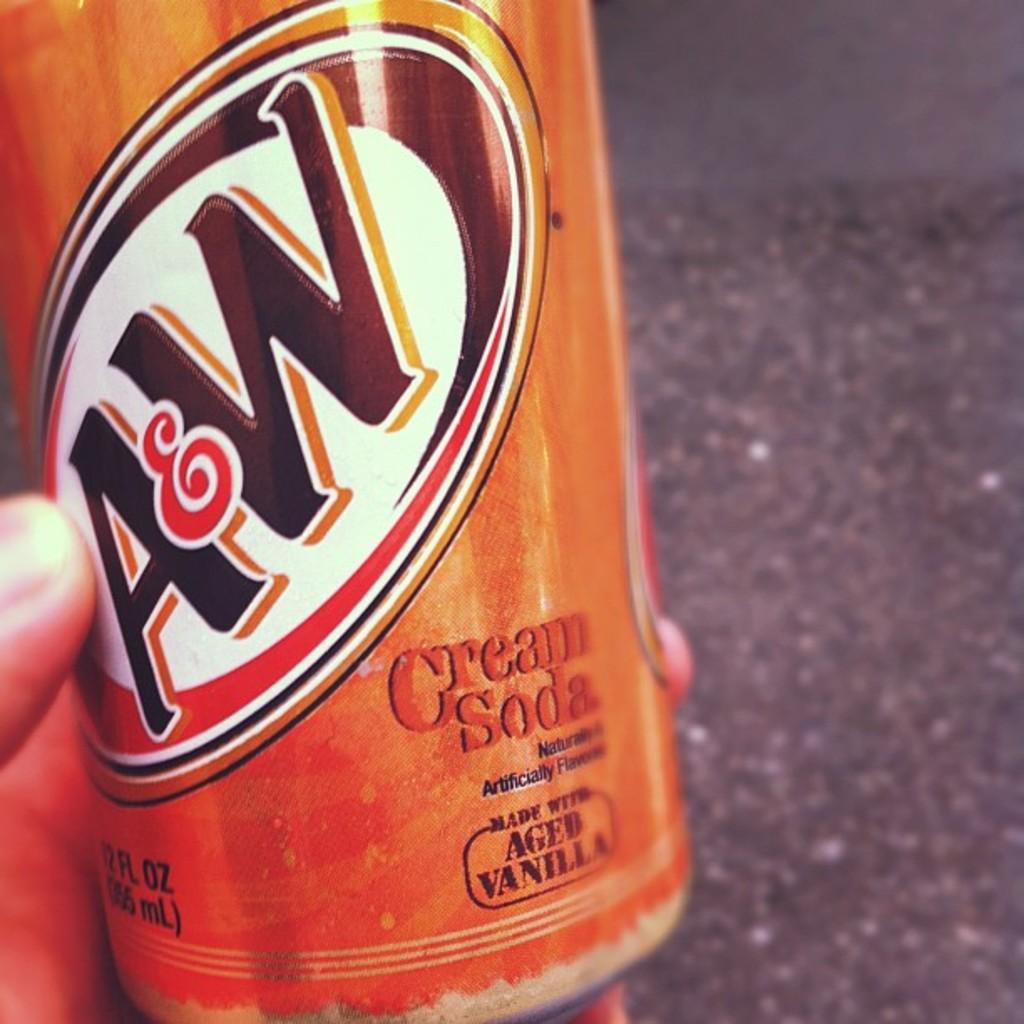<image>
Give a short and clear explanation of the subsequent image. an A and W root beer in a person's hand 